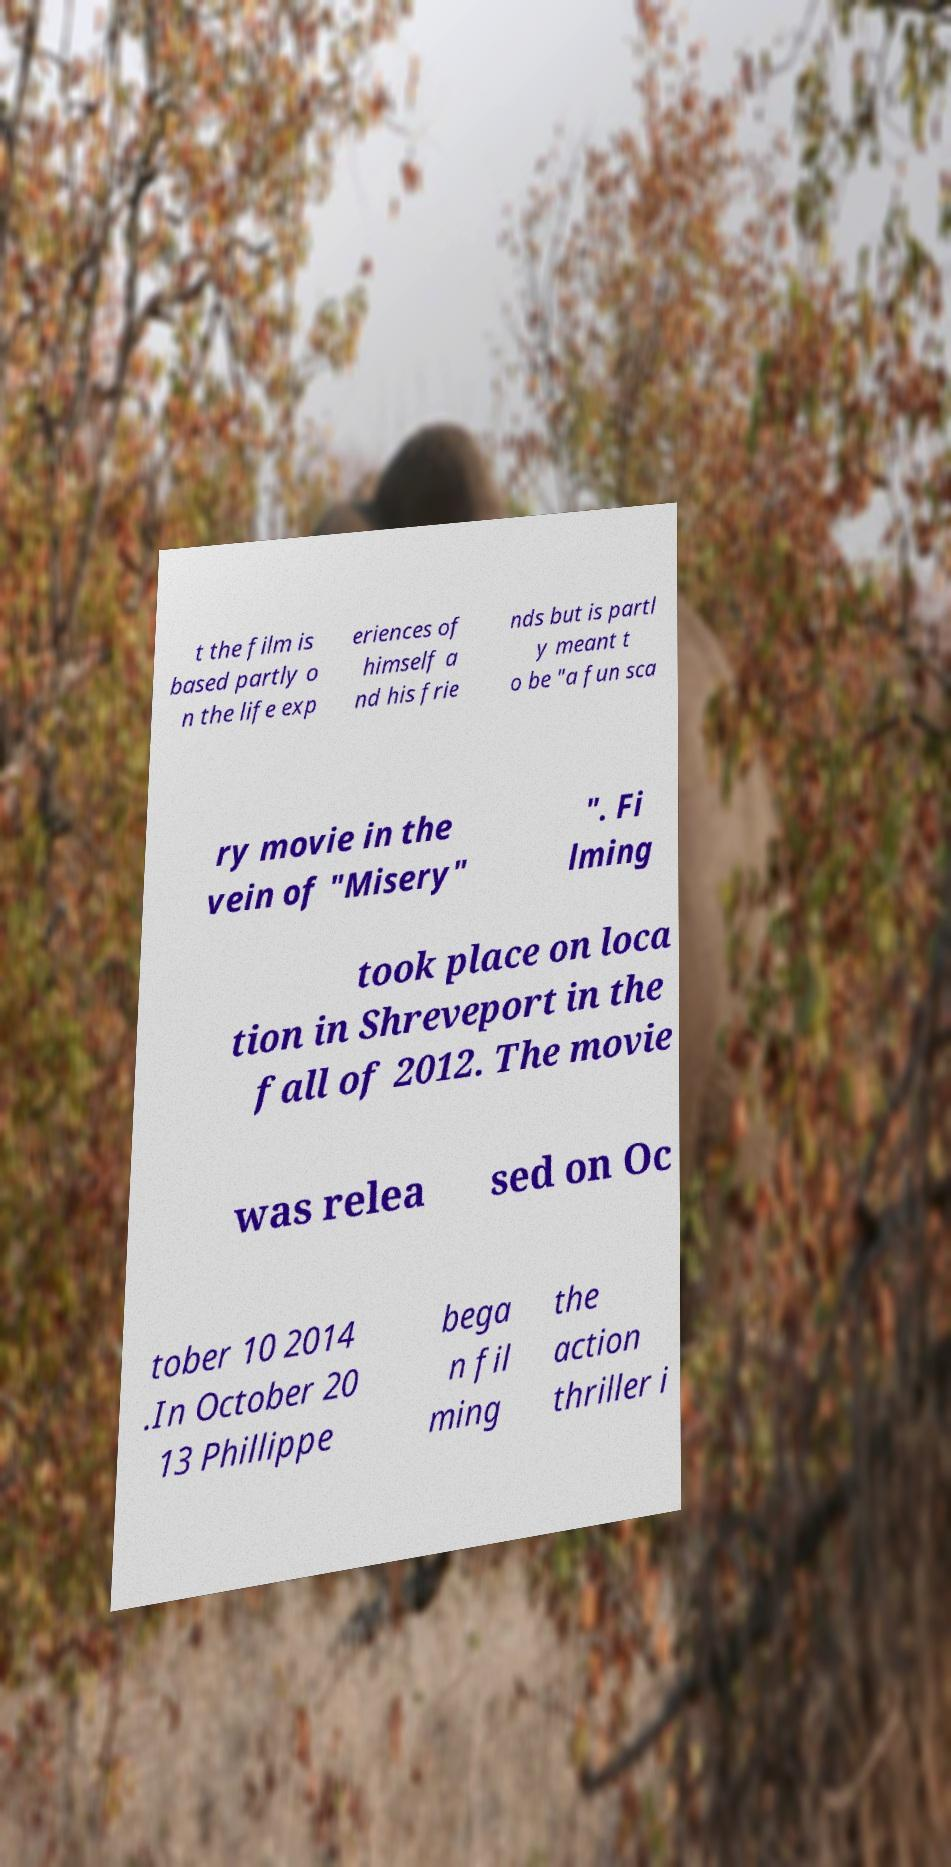There's text embedded in this image that I need extracted. Can you transcribe it verbatim? t the film is based partly o n the life exp eriences of himself a nd his frie nds but is partl y meant t o be "a fun sca ry movie in the vein of "Misery" ". Fi lming took place on loca tion in Shreveport in the fall of 2012. The movie was relea sed on Oc tober 10 2014 .In October 20 13 Phillippe bega n fil ming the action thriller i 